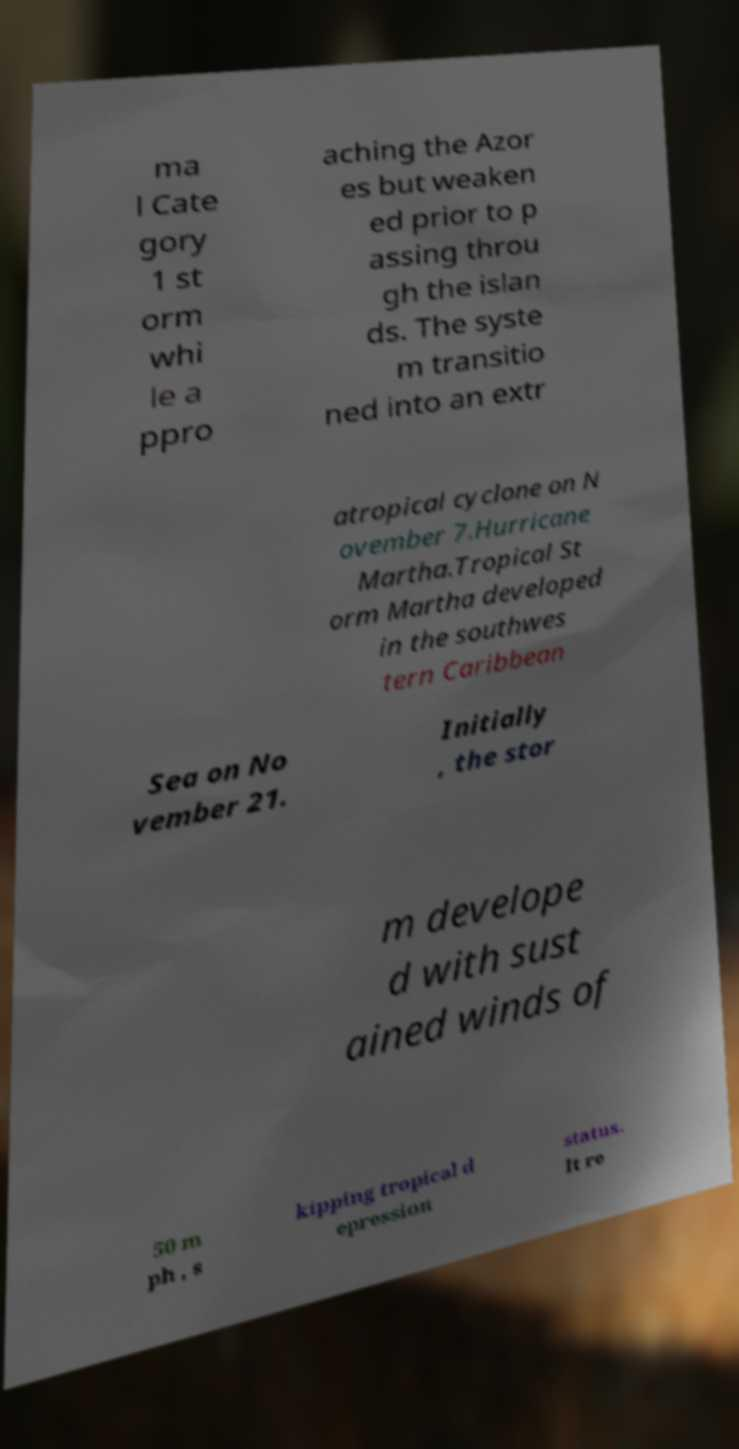For documentation purposes, I need the text within this image transcribed. Could you provide that? ma l Cate gory 1 st orm whi le a ppro aching the Azor es but weaken ed prior to p assing throu gh the islan ds. The syste m transitio ned into an extr atropical cyclone on N ovember 7.Hurricane Martha.Tropical St orm Martha developed in the southwes tern Caribbean Sea on No vember 21. Initially , the stor m develope d with sust ained winds of 50 m ph , s kipping tropical d epression status. It re 